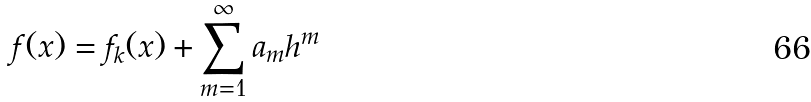<formula> <loc_0><loc_0><loc_500><loc_500>f ( x ) = f _ { k } ( x ) + \sum _ { m = 1 } ^ { \infty } a _ { m } h ^ { m }</formula> 